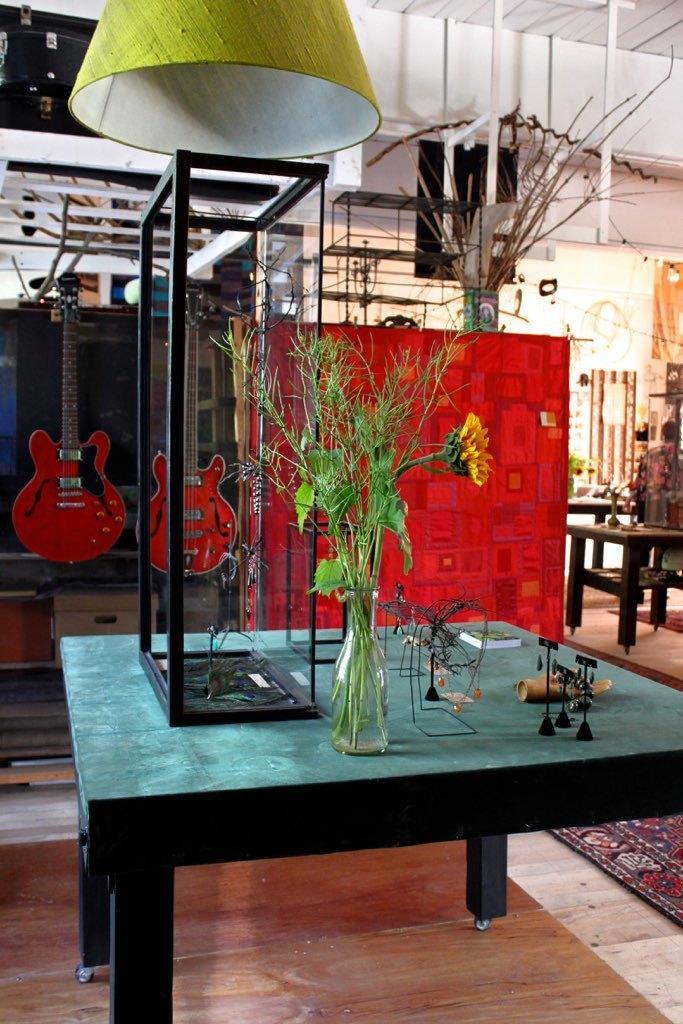Can you describe this image briefly? In this image, There is a table of blue color on that some objects are kept and there is a bottle in which there is green color plant and in the top there is a green color object and in the background there are two red color music instruments. 